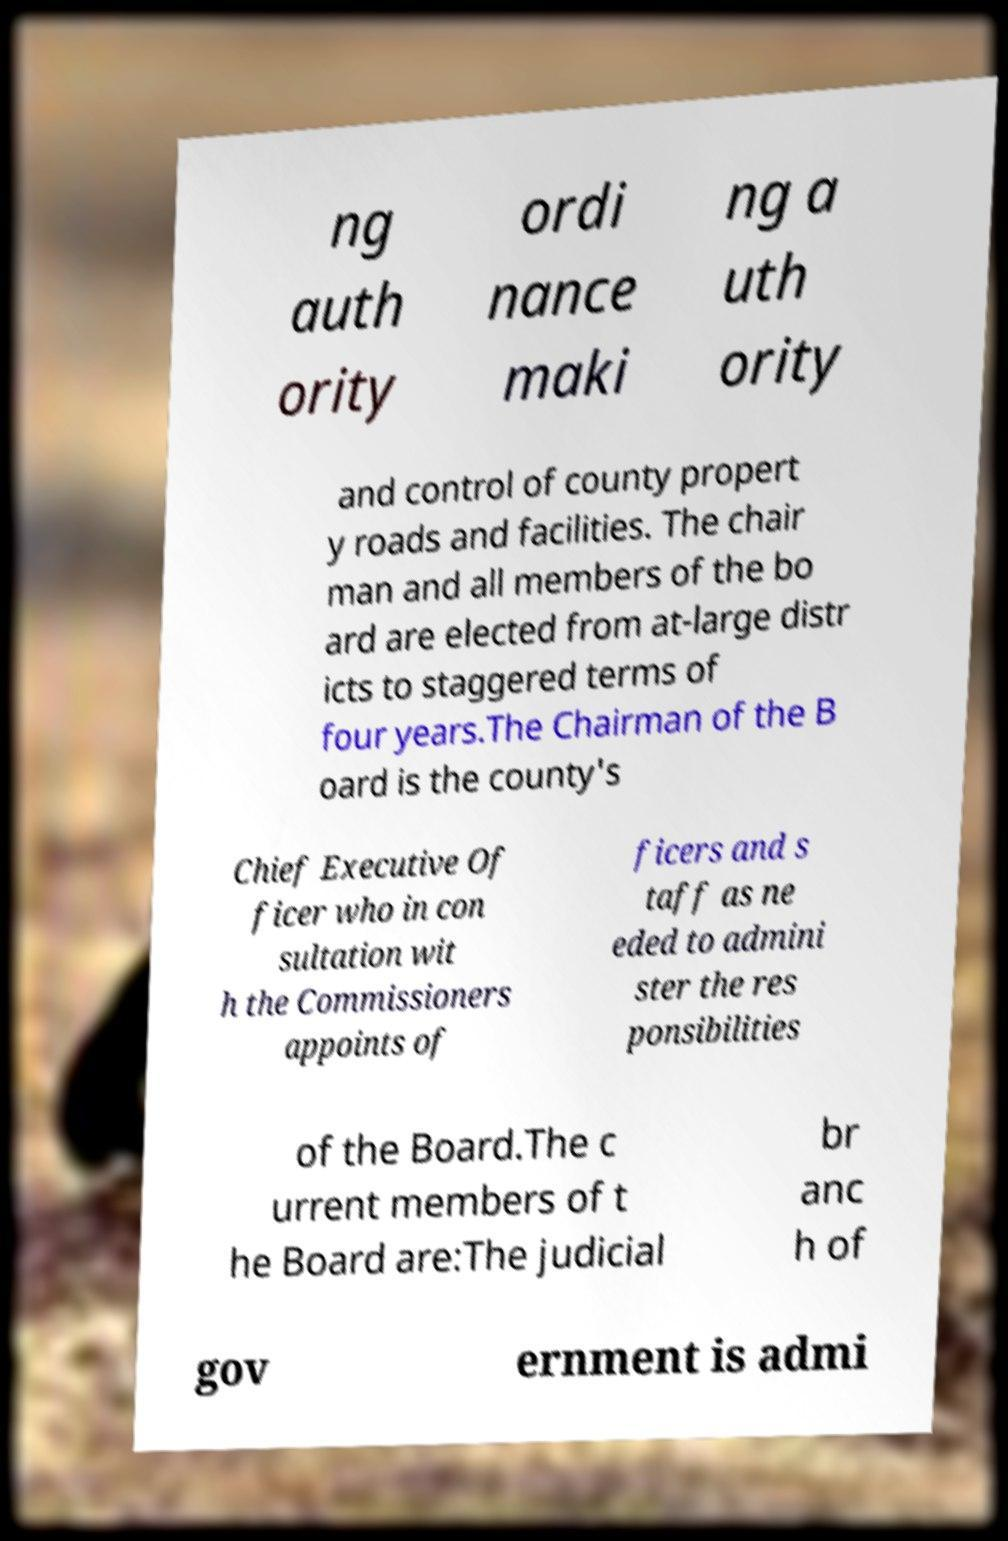Could you extract and type out the text from this image? ng auth ority ordi nance maki ng a uth ority and control of county propert y roads and facilities. The chair man and all members of the bo ard are elected from at-large distr icts to staggered terms of four years.The Chairman of the B oard is the county's Chief Executive Of ficer who in con sultation wit h the Commissioners appoints of ficers and s taff as ne eded to admini ster the res ponsibilities of the Board.The c urrent members of t he Board are:The judicial br anc h of gov ernment is admi 